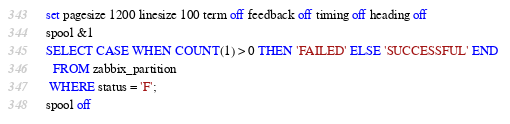<code> <loc_0><loc_0><loc_500><loc_500><_SQL_>set pagesize 1200 linesize 100 term off feedback off timing off heading off
spool &1
SELECT CASE WHEN COUNT(1) > 0 THEN 'FAILED' ELSE 'SUCCESSFUL' END 
  FROM zabbix_partition
 WHERE status = 'F';
spool off</code> 